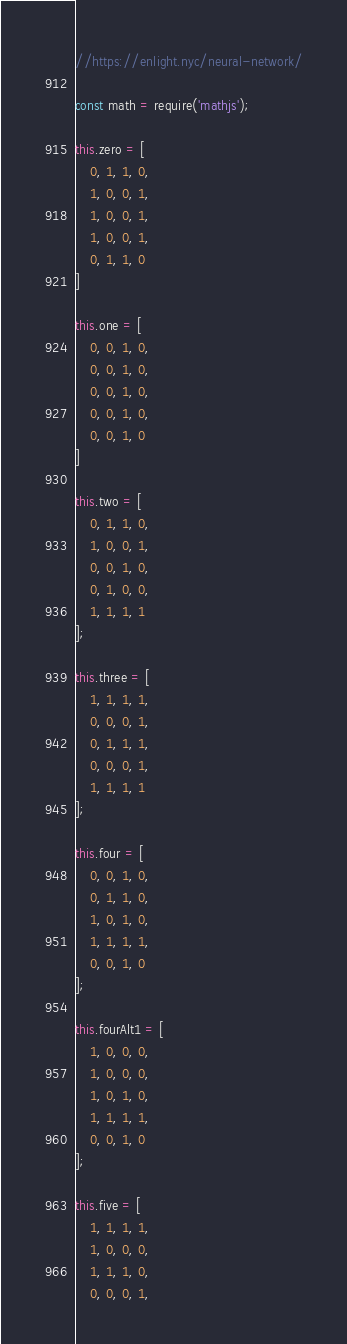<code> <loc_0><loc_0><loc_500><loc_500><_JavaScript_>//https://enlight.nyc/neural-network/

const math = require('mathjs');

this.zero = [
    0, 1, 1, 0,
    1, 0, 0, 1,
    1, 0, 0, 1,
    1, 0, 0, 1,
    0, 1, 1, 0
]

this.one = [
    0, 0, 1, 0,
    0, 0, 1, 0,
    0, 0, 1, 0,
    0, 0, 1, 0,
    0, 0, 1, 0
]

this.two = [
    0, 1, 1, 0,
    1, 0, 0, 1,
    0, 0, 1, 0,
    0, 1, 0, 0,
    1, 1, 1, 1
];

this.three = [
    1, 1, 1, 1,
    0, 0, 0, 1,
    0, 1, 1, 1,
    0, 0, 0, 1,
    1, 1, 1, 1
];

this.four = [
    0, 0, 1, 0,
    0, 1, 1, 0,
    1, 0, 1, 0,
    1, 1, 1, 1,
    0, 0, 1, 0
];

this.fourAlt1 = [
    1, 0, 0, 0,
    1, 0, 0, 0,
    1, 0, 1, 0,
    1, 1, 1, 1,
    0, 0, 1, 0
];

this.five = [
    1, 1, 1, 1,
    1, 0, 0, 0,
    1, 1, 1, 0,
    0, 0, 0, 1,</code> 